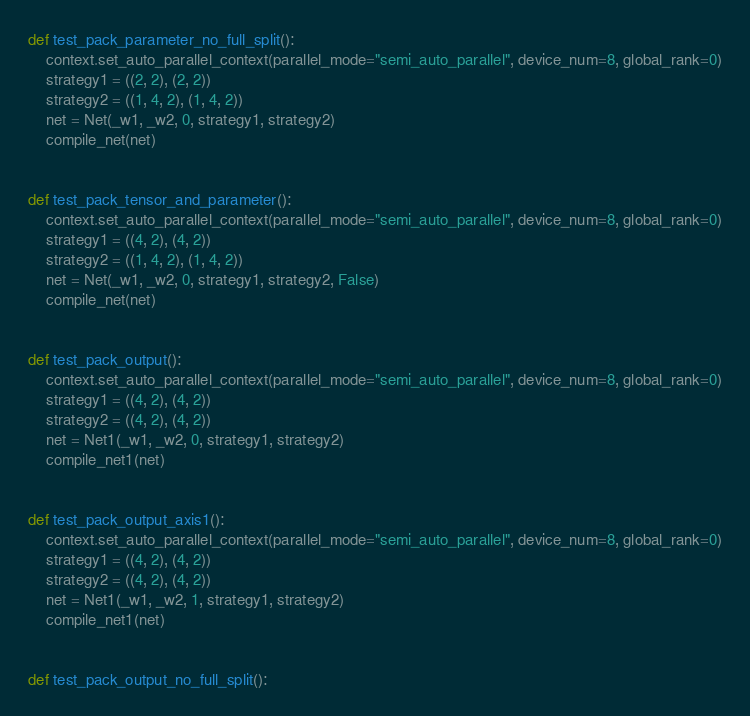<code> <loc_0><loc_0><loc_500><loc_500><_Python_>
def test_pack_parameter_no_full_split():
    context.set_auto_parallel_context(parallel_mode="semi_auto_parallel", device_num=8, global_rank=0)
    strategy1 = ((2, 2), (2, 2))
    strategy2 = ((1, 4, 2), (1, 4, 2))
    net = Net(_w1, _w2, 0, strategy1, strategy2)
    compile_net(net)


def test_pack_tensor_and_parameter():
    context.set_auto_parallel_context(parallel_mode="semi_auto_parallel", device_num=8, global_rank=0)
    strategy1 = ((4, 2), (4, 2))
    strategy2 = ((1, 4, 2), (1, 4, 2))
    net = Net(_w1, _w2, 0, strategy1, strategy2, False)
    compile_net(net)


def test_pack_output():
    context.set_auto_parallel_context(parallel_mode="semi_auto_parallel", device_num=8, global_rank=0)
    strategy1 = ((4, 2), (4, 2))
    strategy2 = ((4, 2), (4, 2))
    net = Net1(_w1, _w2, 0, strategy1, strategy2)
    compile_net1(net)


def test_pack_output_axis1():
    context.set_auto_parallel_context(parallel_mode="semi_auto_parallel", device_num=8, global_rank=0)
    strategy1 = ((4, 2), (4, 2))
    strategy2 = ((4, 2), (4, 2))
    net = Net1(_w1, _w2, 1, strategy1, strategy2)
    compile_net1(net)


def test_pack_output_no_full_split():</code> 